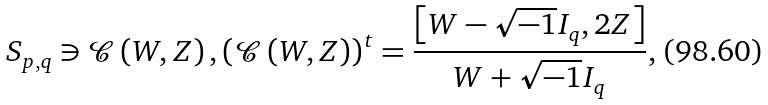<formula> <loc_0><loc_0><loc_500><loc_500>S _ { p , q } \ni \mathcal { C } \left ( W , Z \right ) , \left ( \mathcal { C } \left ( W , Z \right ) \right ) ^ { t } = \frac { \left [ W - \sqrt { - 1 } I _ { q } , 2 Z \right ] } { W + \sqrt { - 1 } I _ { q } } ,</formula> 